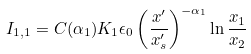Convert formula to latex. <formula><loc_0><loc_0><loc_500><loc_500>I _ { 1 , 1 } = C ( \alpha _ { 1 } ) K _ { 1 } \epsilon _ { 0 } \left ( \frac { x ^ { \prime } } { x ^ { \prime } _ { s } } \right ) ^ { - \alpha _ { 1 } } \ln \frac { x _ { 1 } } { x _ { 2 } }</formula> 